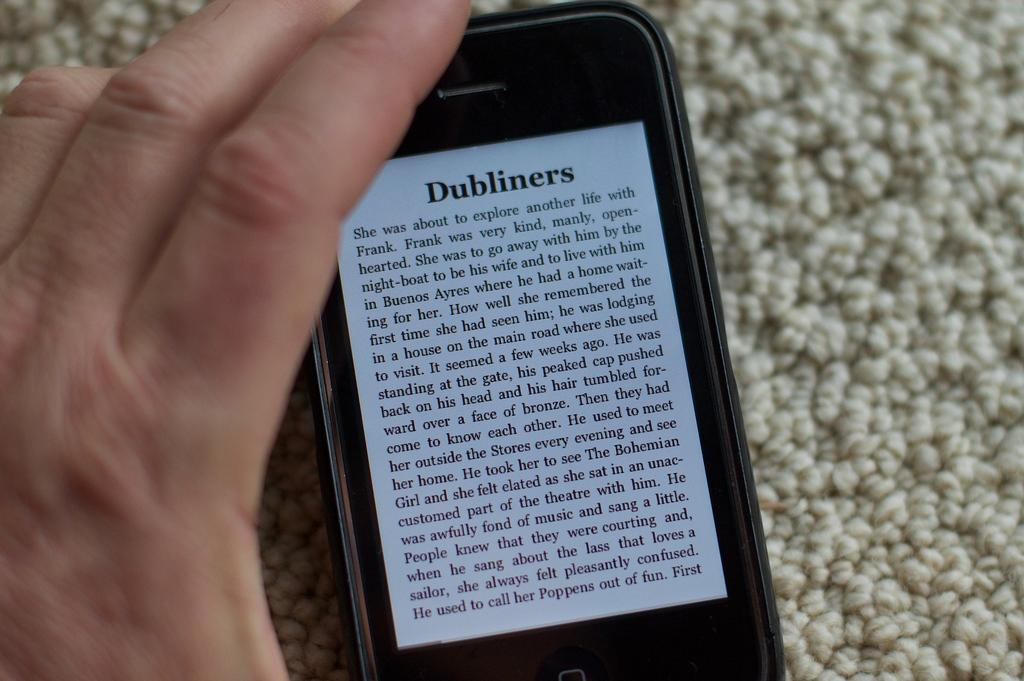Provide a one-sentence caption for the provided image. A text on a smart phone that is titled Dubliners. 